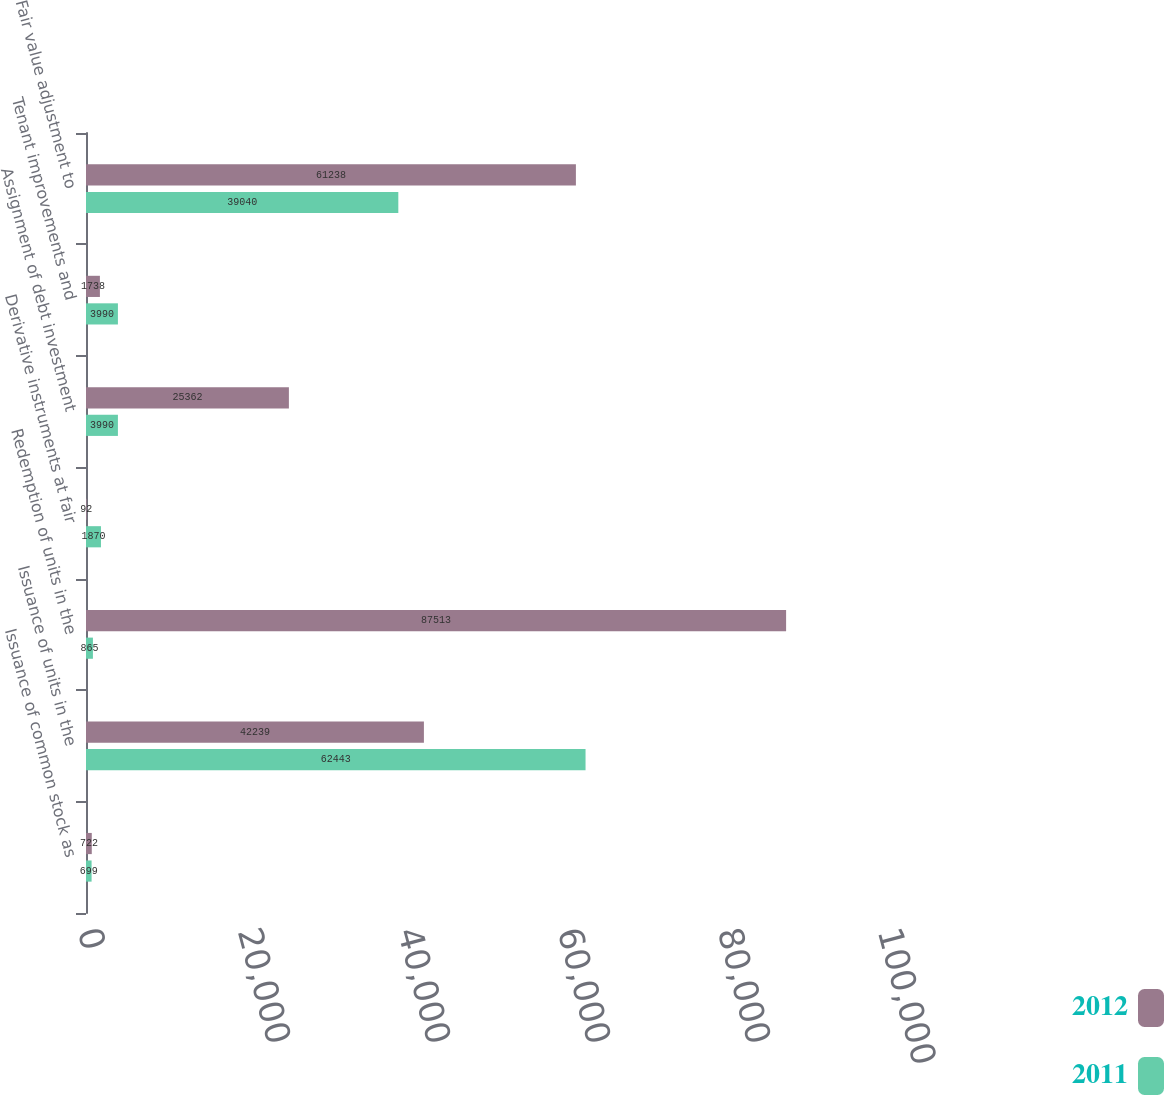Convert chart. <chart><loc_0><loc_0><loc_500><loc_500><stacked_bar_chart><ecel><fcel>Issuance of common stock as<fcel>Issuance of units in the<fcel>Redemption of units in the<fcel>Derivative instruments at fair<fcel>Assignment of debt investment<fcel>Tenant improvements and<fcel>Fair value adjustment to<nl><fcel>2012<fcel>722<fcel>42239<fcel>87513<fcel>92<fcel>25362<fcel>1738<fcel>61238<nl><fcel>2011<fcel>699<fcel>62443<fcel>865<fcel>1870<fcel>3990<fcel>3990<fcel>39040<nl></chart> 